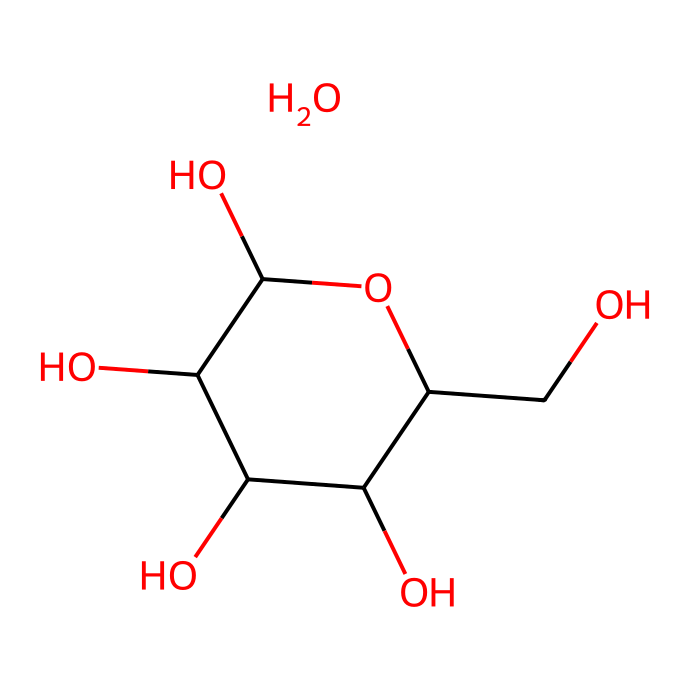What is the name of this chemical? The SMILES representation corresponds to the structure of a polysaccharide, specifically starch or its derivatives. Since cornstarch is primarily composed of amylopectin and amylose, which are polysaccharides, the name of the chemical is based on these components.
Answer: starch How many carbon atoms are present in this molecule? By examining the SMILES representation, we can count the occurrences of the letter 'C'. There are 9 carbon atoms in total visible from the structure provided.
Answer: 9 What type of bonding is primarily present in this chemical? The structure shows that it consists of carbon, hydrogen, and oxygen atoms, which are predominantly linked by covalent bonds as typically seen in organic molecules.
Answer: covalent Is this a soluble compound in water? Given that the structure consists of hydroxyl (-OH) groups, which are polar, it indicates that this compound is typically soluble in water, as polar substances tend to dissolve easily in polar solvents.
Answer: yes What property describes the behavior of this chemical as a non-Newtonian fluid? Cornstarch suspended in water exhibits shear-thickening behavior when force is applied, meaning that it becomes more viscous or thick under stress, a characteristic of many non-Newtonian fluids.
Answer: shear-thickening How many hydroxyl groups are indicated in the structure? Each 'O' in the hydroxyl groups represents a -OH group, and by examining the structure, we can see that there are 5 hydroxyl groups in total.
Answer: 5 What is the effect of heating this chemical in terms of its viscosity? When heated, the viscosity of a cornstarch-water mixture decreases as the starch granules gelatinize, allowing the mixture to flow more easily at higher temperatures, thus changing its non-Newtonian behavior.
Answer: decrease 